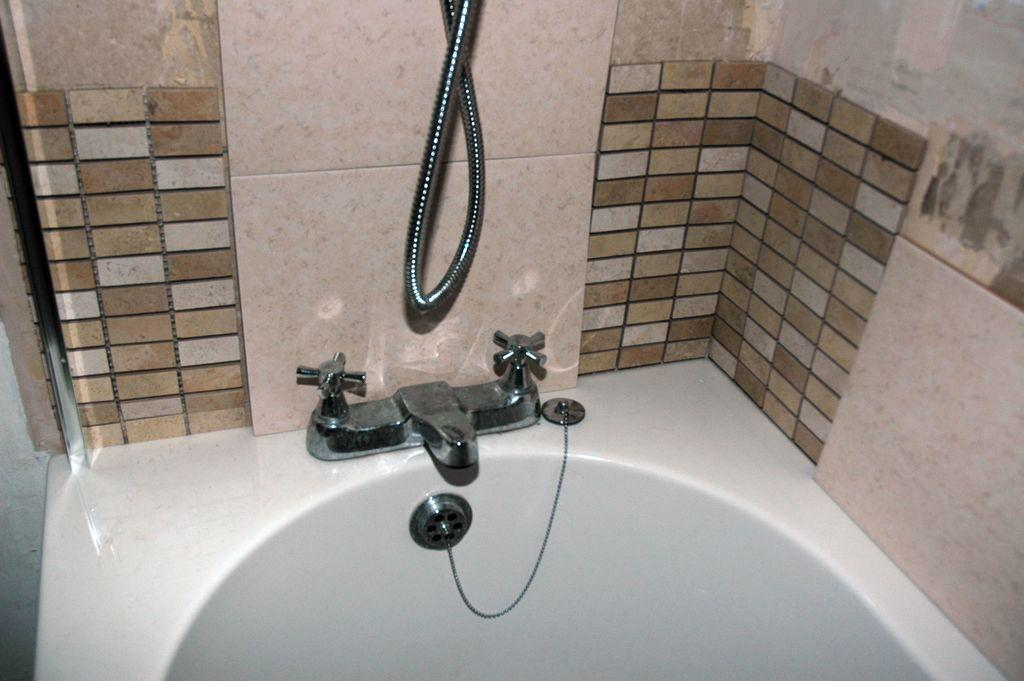What is the main object in the image? There is a bathtub in the image. What can be used to control the flow of water in the bathtub? There are taps in the image. What is used to hang the showerhead in the image? There is a shower-wire in the image. What can be seen behind the bathtub in the image? There is a wall visible in the image. How many baby planes are flying around the bathtub in the image? There are no baby planes present in the image; it features a bathtub with taps and a shower-wire. What type of apparel is the bathtub wearing in the image? The bathtub is not wearing any apparel; it is an inanimate object. 